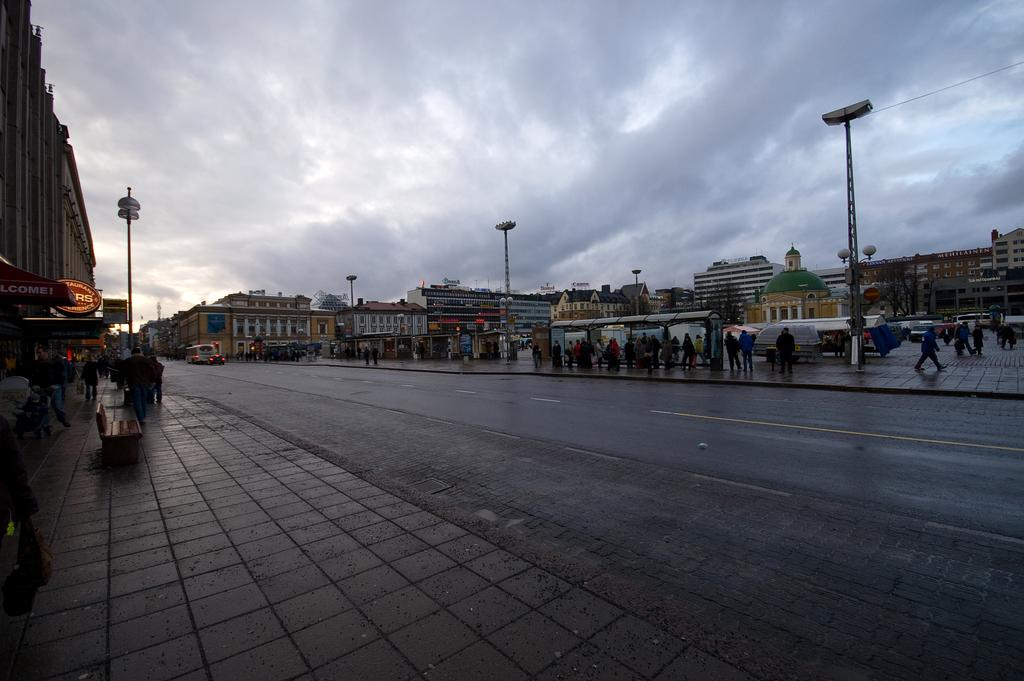What is the main feature of the image? There is a road in the image. What can be seen alongside the road? There are people on the footpaths and poles on the footpaths. What type of establishments are present in the image? There are stores in the image. What type of structures are visible in the image? There are buildings in the image. What shape is the rock that the pan is sitting on in the image? There is no rock or pan present in the image. 